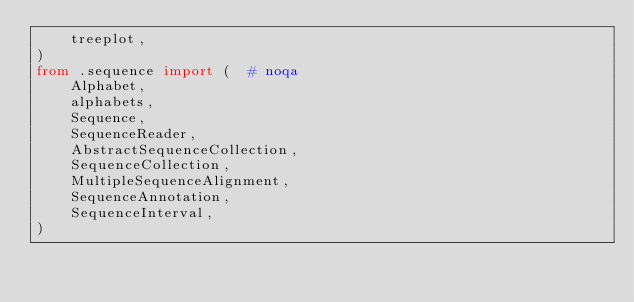<code> <loc_0><loc_0><loc_500><loc_500><_Python_>    treeplot,
)
from .sequence import (  # noqa
    Alphabet,
    alphabets,
    Sequence,
    SequenceReader,
    AbstractSequenceCollection,
    SequenceCollection,
    MultipleSequenceAlignment,
    SequenceAnnotation,
    SequenceInterval,
)
</code> 